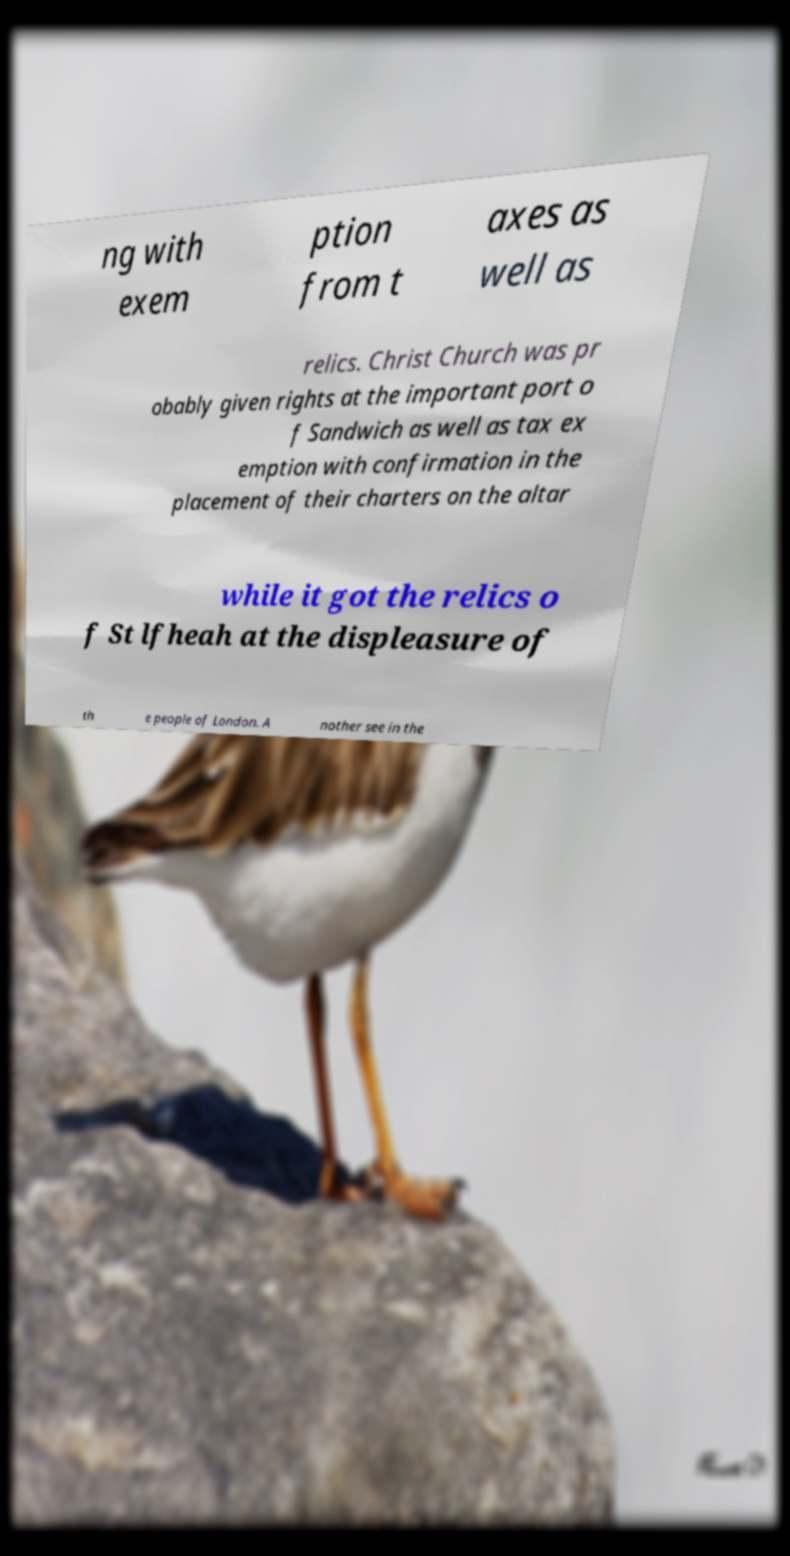There's text embedded in this image that I need extracted. Can you transcribe it verbatim? ng with exem ption from t axes as well as relics. Christ Church was pr obably given rights at the important port o f Sandwich as well as tax ex emption with confirmation in the placement of their charters on the altar while it got the relics o f St lfheah at the displeasure of th e people of London. A nother see in the 